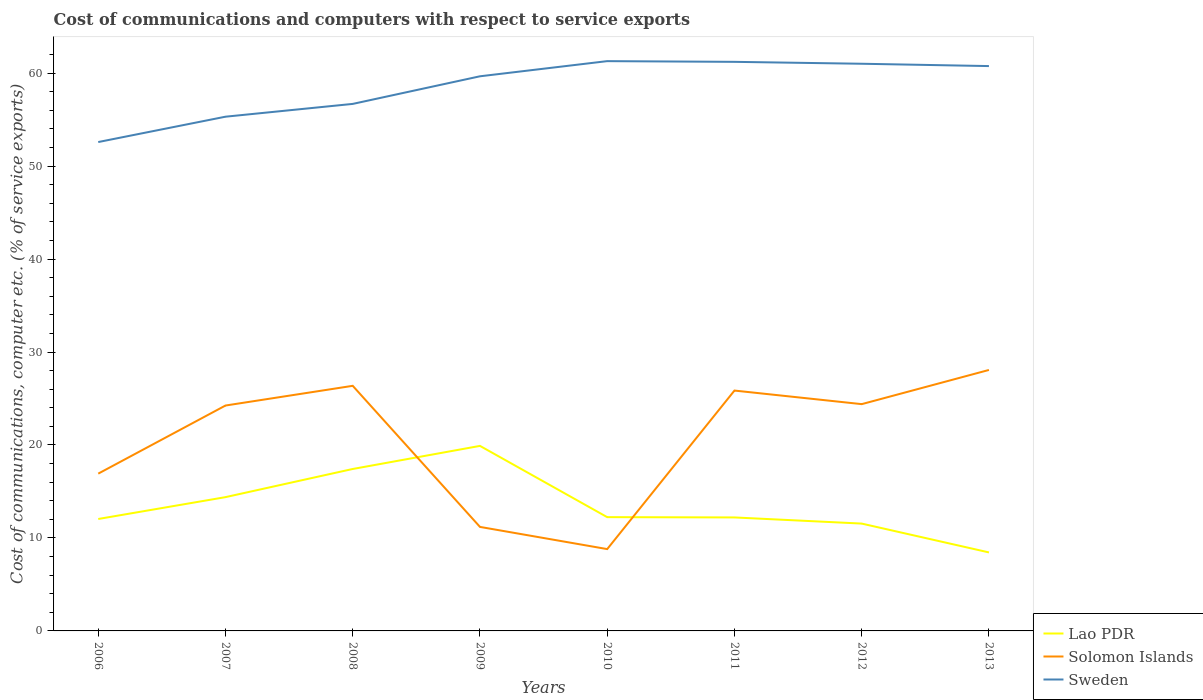Does the line corresponding to Solomon Islands intersect with the line corresponding to Lao PDR?
Your answer should be compact. Yes. Across all years, what is the maximum cost of communications and computers in Solomon Islands?
Keep it short and to the point. 8.8. In which year was the cost of communications and computers in Lao PDR maximum?
Offer a terse response. 2013. What is the total cost of communications and computers in Solomon Islands in the graph?
Ensure brevity in your answer.  8.12. What is the difference between the highest and the second highest cost of communications and computers in Solomon Islands?
Give a very brief answer. 19.27. What is the difference between the highest and the lowest cost of communications and computers in Sweden?
Your response must be concise. 5. Is the cost of communications and computers in Lao PDR strictly greater than the cost of communications and computers in Sweden over the years?
Keep it short and to the point. Yes. How many years are there in the graph?
Ensure brevity in your answer.  8. Does the graph contain any zero values?
Your response must be concise. No. Does the graph contain grids?
Make the answer very short. No. Where does the legend appear in the graph?
Offer a very short reply. Bottom right. How are the legend labels stacked?
Keep it short and to the point. Vertical. What is the title of the graph?
Make the answer very short. Cost of communications and computers with respect to service exports. What is the label or title of the X-axis?
Make the answer very short. Years. What is the label or title of the Y-axis?
Provide a short and direct response. Cost of communications, computer etc. (% of service exports). What is the Cost of communications, computer etc. (% of service exports) in Lao PDR in 2006?
Offer a terse response. 12.04. What is the Cost of communications, computer etc. (% of service exports) in Solomon Islands in 2006?
Offer a terse response. 16.92. What is the Cost of communications, computer etc. (% of service exports) of Sweden in 2006?
Provide a succinct answer. 52.59. What is the Cost of communications, computer etc. (% of service exports) of Lao PDR in 2007?
Your answer should be very brief. 14.39. What is the Cost of communications, computer etc. (% of service exports) in Solomon Islands in 2007?
Your answer should be compact. 24.25. What is the Cost of communications, computer etc. (% of service exports) in Sweden in 2007?
Your answer should be compact. 55.32. What is the Cost of communications, computer etc. (% of service exports) of Lao PDR in 2008?
Provide a short and direct response. 17.42. What is the Cost of communications, computer etc. (% of service exports) of Solomon Islands in 2008?
Your answer should be very brief. 26.37. What is the Cost of communications, computer etc. (% of service exports) of Sweden in 2008?
Your answer should be compact. 56.69. What is the Cost of communications, computer etc. (% of service exports) of Lao PDR in 2009?
Keep it short and to the point. 19.9. What is the Cost of communications, computer etc. (% of service exports) in Solomon Islands in 2009?
Your response must be concise. 11.19. What is the Cost of communications, computer etc. (% of service exports) of Sweden in 2009?
Keep it short and to the point. 59.66. What is the Cost of communications, computer etc. (% of service exports) of Lao PDR in 2010?
Your response must be concise. 12.24. What is the Cost of communications, computer etc. (% of service exports) in Solomon Islands in 2010?
Ensure brevity in your answer.  8.8. What is the Cost of communications, computer etc. (% of service exports) of Sweden in 2010?
Make the answer very short. 61.29. What is the Cost of communications, computer etc. (% of service exports) in Lao PDR in 2011?
Your answer should be compact. 12.21. What is the Cost of communications, computer etc. (% of service exports) in Solomon Islands in 2011?
Your answer should be very brief. 25.86. What is the Cost of communications, computer etc. (% of service exports) in Sweden in 2011?
Give a very brief answer. 61.22. What is the Cost of communications, computer etc. (% of service exports) of Lao PDR in 2012?
Ensure brevity in your answer.  11.55. What is the Cost of communications, computer etc. (% of service exports) in Solomon Islands in 2012?
Make the answer very short. 24.4. What is the Cost of communications, computer etc. (% of service exports) of Sweden in 2012?
Offer a terse response. 61.01. What is the Cost of communications, computer etc. (% of service exports) in Lao PDR in 2013?
Keep it short and to the point. 8.45. What is the Cost of communications, computer etc. (% of service exports) in Solomon Islands in 2013?
Your response must be concise. 28.07. What is the Cost of communications, computer etc. (% of service exports) in Sweden in 2013?
Give a very brief answer. 60.76. Across all years, what is the maximum Cost of communications, computer etc. (% of service exports) in Lao PDR?
Keep it short and to the point. 19.9. Across all years, what is the maximum Cost of communications, computer etc. (% of service exports) in Solomon Islands?
Provide a succinct answer. 28.07. Across all years, what is the maximum Cost of communications, computer etc. (% of service exports) in Sweden?
Offer a terse response. 61.29. Across all years, what is the minimum Cost of communications, computer etc. (% of service exports) of Lao PDR?
Your response must be concise. 8.45. Across all years, what is the minimum Cost of communications, computer etc. (% of service exports) of Solomon Islands?
Provide a short and direct response. 8.8. Across all years, what is the minimum Cost of communications, computer etc. (% of service exports) in Sweden?
Provide a short and direct response. 52.59. What is the total Cost of communications, computer etc. (% of service exports) in Lao PDR in the graph?
Offer a very short reply. 108.19. What is the total Cost of communications, computer etc. (% of service exports) of Solomon Islands in the graph?
Offer a terse response. 165.85. What is the total Cost of communications, computer etc. (% of service exports) in Sweden in the graph?
Your response must be concise. 468.54. What is the difference between the Cost of communications, computer etc. (% of service exports) of Lao PDR in 2006 and that in 2007?
Your answer should be compact. -2.35. What is the difference between the Cost of communications, computer etc. (% of service exports) in Solomon Islands in 2006 and that in 2007?
Provide a succinct answer. -7.33. What is the difference between the Cost of communications, computer etc. (% of service exports) of Sweden in 2006 and that in 2007?
Give a very brief answer. -2.73. What is the difference between the Cost of communications, computer etc. (% of service exports) in Lao PDR in 2006 and that in 2008?
Give a very brief answer. -5.38. What is the difference between the Cost of communications, computer etc. (% of service exports) in Solomon Islands in 2006 and that in 2008?
Make the answer very short. -9.45. What is the difference between the Cost of communications, computer etc. (% of service exports) in Sweden in 2006 and that in 2008?
Your answer should be compact. -4.1. What is the difference between the Cost of communications, computer etc. (% of service exports) of Lao PDR in 2006 and that in 2009?
Ensure brevity in your answer.  -7.86. What is the difference between the Cost of communications, computer etc. (% of service exports) of Solomon Islands in 2006 and that in 2009?
Make the answer very short. 5.73. What is the difference between the Cost of communications, computer etc. (% of service exports) in Sweden in 2006 and that in 2009?
Keep it short and to the point. -7.07. What is the difference between the Cost of communications, computer etc. (% of service exports) in Lao PDR in 2006 and that in 2010?
Keep it short and to the point. -0.2. What is the difference between the Cost of communications, computer etc. (% of service exports) of Solomon Islands in 2006 and that in 2010?
Your answer should be very brief. 8.12. What is the difference between the Cost of communications, computer etc. (% of service exports) in Sweden in 2006 and that in 2010?
Your answer should be very brief. -8.7. What is the difference between the Cost of communications, computer etc. (% of service exports) of Lao PDR in 2006 and that in 2011?
Give a very brief answer. -0.17. What is the difference between the Cost of communications, computer etc. (% of service exports) in Solomon Islands in 2006 and that in 2011?
Provide a short and direct response. -8.94. What is the difference between the Cost of communications, computer etc. (% of service exports) of Sweden in 2006 and that in 2011?
Provide a short and direct response. -8.63. What is the difference between the Cost of communications, computer etc. (% of service exports) of Lao PDR in 2006 and that in 2012?
Offer a terse response. 0.49. What is the difference between the Cost of communications, computer etc. (% of service exports) of Solomon Islands in 2006 and that in 2012?
Make the answer very short. -7.48. What is the difference between the Cost of communications, computer etc. (% of service exports) in Sweden in 2006 and that in 2012?
Offer a terse response. -8.42. What is the difference between the Cost of communications, computer etc. (% of service exports) in Lao PDR in 2006 and that in 2013?
Provide a short and direct response. 3.6. What is the difference between the Cost of communications, computer etc. (% of service exports) in Solomon Islands in 2006 and that in 2013?
Offer a terse response. -11.15. What is the difference between the Cost of communications, computer etc. (% of service exports) of Sweden in 2006 and that in 2013?
Offer a terse response. -8.17. What is the difference between the Cost of communications, computer etc. (% of service exports) of Lao PDR in 2007 and that in 2008?
Keep it short and to the point. -3.03. What is the difference between the Cost of communications, computer etc. (% of service exports) in Solomon Islands in 2007 and that in 2008?
Provide a succinct answer. -2.12. What is the difference between the Cost of communications, computer etc. (% of service exports) of Sweden in 2007 and that in 2008?
Provide a succinct answer. -1.38. What is the difference between the Cost of communications, computer etc. (% of service exports) of Lao PDR in 2007 and that in 2009?
Your answer should be compact. -5.51. What is the difference between the Cost of communications, computer etc. (% of service exports) of Solomon Islands in 2007 and that in 2009?
Your answer should be compact. 13.06. What is the difference between the Cost of communications, computer etc. (% of service exports) of Sweden in 2007 and that in 2009?
Provide a succinct answer. -4.35. What is the difference between the Cost of communications, computer etc. (% of service exports) of Lao PDR in 2007 and that in 2010?
Offer a very short reply. 2.15. What is the difference between the Cost of communications, computer etc. (% of service exports) of Solomon Islands in 2007 and that in 2010?
Ensure brevity in your answer.  15.44. What is the difference between the Cost of communications, computer etc. (% of service exports) of Sweden in 2007 and that in 2010?
Provide a short and direct response. -5.98. What is the difference between the Cost of communications, computer etc. (% of service exports) in Lao PDR in 2007 and that in 2011?
Give a very brief answer. 2.18. What is the difference between the Cost of communications, computer etc. (% of service exports) of Solomon Islands in 2007 and that in 2011?
Your response must be concise. -1.61. What is the difference between the Cost of communications, computer etc. (% of service exports) in Sweden in 2007 and that in 2011?
Offer a terse response. -5.9. What is the difference between the Cost of communications, computer etc. (% of service exports) in Lao PDR in 2007 and that in 2012?
Provide a succinct answer. 2.84. What is the difference between the Cost of communications, computer etc. (% of service exports) in Solomon Islands in 2007 and that in 2012?
Keep it short and to the point. -0.15. What is the difference between the Cost of communications, computer etc. (% of service exports) of Sweden in 2007 and that in 2012?
Your answer should be compact. -5.7. What is the difference between the Cost of communications, computer etc. (% of service exports) of Lao PDR in 2007 and that in 2013?
Ensure brevity in your answer.  5.95. What is the difference between the Cost of communications, computer etc. (% of service exports) in Solomon Islands in 2007 and that in 2013?
Make the answer very short. -3.83. What is the difference between the Cost of communications, computer etc. (% of service exports) in Sweden in 2007 and that in 2013?
Offer a terse response. -5.45. What is the difference between the Cost of communications, computer etc. (% of service exports) of Lao PDR in 2008 and that in 2009?
Your answer should be compact. -2.48. What is the difference between the Cost of communications, computer etc. (% of service exports) of Solomon Islands in 2008 and that in 2009?
Your answer should be compact. 15.18. What is the difference between the Cost of communications, computer etc. (% of service exports) of Sweden in 2008 and that in 2009?
Your response must be concise. -2.97. What is the difference between the Cost of communications, computer etc. (% of service exports) of Lao PDR in 2008 and that in 2010?
Your answer should be compact. 5.18. What is the difference between the Cost of communications, computer etc. (% of service exports) in Solomon Islands in 2008 and that in 2010?
Make the answer very short. 17.56. What is the difference between the Cost of communications, computer etc. (% of service exports) in Sweden in 2008 and that in 2010?
Provide a short and direct response. -4.6. What is the difference between the Cost of communications, computer etc. (% of service exports) in Lao PDR in 2008 and that in 2011?
Your answer should be compact. 5.21. What is the difference between the Cost of communications, computer etc. (% of service exports) of Solomon Islands in 2008 and that in 2011?
Your answer should be very brief. 0.51. What is the difference between the Cost of communications, computer etc. (% of service exports) in Sweden in 2008 and that in 2011?
Keep it short and to the point. -4.53. What is the difference between the Cost of communications, computer etc. (% of service exports) of Lao PDR in 2008 and that in 2012?
Provide a short and direct response. 5.87. What is the difference between the Cost of communications, computer etc. (% of service exports) of Solomon Islands in 2008 and that in 2012?
Give a very brief answer. 1.97. What is the difference between the Cost of communications, computer etc. (% of service exports) in Sweden in 2008 and that in 2012?
Give a very brief answer. -4.32. What is the difference between the Cost of communications, computer etc. (% of service exports) of Lao PDR in 2008 and that in 2013?
Your response must be concise. 8.97. What is the difference between the Cost of communications, computer etc. (% of service exports) in Solomon Islands in 2008 and that in 2013?
Your response must be concise. -1.71. What is the difference between the Cost of communications, computer etc. (% of service exports) in Sweden in 2008 and that in 2013?
Ensure brevity in your answer.  -4.07. What is the difference between the Cost of communications, computer etc. (% of service exports) in Lao PDR in 2009 and that in 2010?
Give a very brief answer. 7.67. What is the difference between the Cost of communications, computer etc. (% of service exports) of Solomon Islands in 2009 and that in 2010?
Offer a very short reply. 2.39. What is the difference between the Cost of communications, computer etc. (% of service exports) in Sweden in 2009 and that in 2010?
Ensure brevity in your answer.  -1.63. What is the difference between the Cost of communications, computer etc. (% of service exports) of Lao PDR in 2009 and that in 2011?
Provide a succinct answer. 7.7. What is the difference between the Cost of communications, computer etc. (% of service exports) of Solomon Islands in 2009 and that in 2011?
Provide a succinct answer. -14.67. What is the difference between the Cost of communications, computer etc. (% of service exports) in Sweden in 2009 and that in 2011?
Offer a terse response. -1.56. What is the difference between the Cost of communications, computer etc. (% of service exports) in Lao PDR in 2009 and that in 2012?
Ensure brevity in your answer.  8.36. What is the difference between the Cost of communications, computer etc. (% of service exports) in Solomon Islands in 2009 and that in 2012?
Your response must be concise. -13.21. What is the difference between the Cost of communications, computer etc. (% of service exports) of Sweden in 2009 and that in 2012?
Ensure brevity in your answer.  -1.35. What is the difference between the Cost of communications, computer etc. (% of service exports) of Lao PDR in 2009 and that in 2013?
Ensure brevity in your answer.  11.46. What is the difference between the Cost of communications, computer etc. (% of service exports) of Solomon Islands in 2009 and that in 2013?
Provide a succinct answer. -16.88. What is the difference between the Cost of communications, computer etc. (% of service exports) of Sweden in 2009 and that in 2013?
Provide a succinct answer. -1.1. What is the difference between the Cost of communications, computer etc. (% of service exports) in Lao PDR in 2010 and that in 2011?
Offer a terse response. 0.03. What is the difference between the Cost of communications, computer etc. (% of service exports) in Solomon Islands in 2010 and that in 2011?
Provide a short and direct response. -17.05. What is the difference between the Cost of communications, computer etc. (% of service exports) in Sweden in 2010 and that in 2011?
Offer a very short reply. 0.08. What is the difference between the Cost of communications, computer etc. (% of service exports) of Lao PDR in 2010 and that in 2012?
Offer a very short reply. 0.69. What is the difference between the Cost of communications, computer etc. (% of service exports) in Solomon Islands in 2010 and that in 2012?
Give a very brief answer. -15.59. What is the difference between the Cost of communications, computer etc. (% of service exports) of Sweden in 2010 and that in 2012?
Your response must be concise. 0.28. What is the difference between the Cost of communications, computer etc. (% of service exports) in Lao PDR in 2010 and that in 2013?
Your answer should be compact. 3.79. What is the difference between the Cost of communications, computer etc. (% of service exports) in Solomon Islands in 2010 and that in 2013?
Ensure brevity in your answer.  -19.27. What is the difference between the Cost of communications, computer etc. (% of service exports) in Sweden in 2010 and that in 2013?
Provide a short and direct response. 0.53. What is the difference between the Cost of communications, computer etc. (% of service exports) of Lao PDR in 2011 and that in 2012?
Provide a succinct answer. 0.66. What is the difference between the Cost of communications, computer etc. (% of service exports) in Solomon Islands in 2011 and that in 2012?
Your answer should be compact. 1.46. What is the difference between the Cost of communications, computer etc. (% of service exports) of Sweden in 2011 and that in 2012?
Keep it short and to the point. 0.21. What is the difference between the Cost of communications, computer etc. (% of service exports) in Lao PDR in 2011 and that in 2013?
Offer a terse response. 3.76. What is the difference between the Cost of communications, computer etc. (% of service exports) in Solomon Islands in 2011 and that in 2013?
Make the answer very short. -2.22. What is the difference between the Cost of communications, computer etc. (% of service exports) in Sweden in 2011 and that in 2013?
Ensure brevity in your answer.  0.46. What is the difference between the Cost of communications, computer etc. (% of service exports) in Lao PDR in 2012 and that in 2013?
Keep it short and to the point. 3.1. What is the difference between the Cost of communications, computer etc. (% of service exports) in Solomon Islands in 2012 and that in 2013?
Ensure brevity in your answer.  -3.68. What is the difference between the Cost of communications, computer etc. (% of service exports) of Sweden in 2012 and that in 2013?
Keep it short and to the point. 0.25. What is the difference between the Cost of communications, computer etc. (% of service exports) in Lao PDR in 2006 and the Cost of communications, computer etc. (% of service exports) in Solomon Islands in 2007?
Provide a succinct answer. -12.2. What is the difference between the Cost of communications, computer etc. (% of service exports) in Lao PDR in 2006 and the Cost of communications, computer etc. (% of service exports) in Sweden in 2007?
Your answer should be very brief. -43.27. What is the difference between the Cost of communications, computer etc. (% of service exports) of Solomon Islands in 2006 and the Cost of communications, computer etc. (% of service exports) of Sweden in 2007?
Give a very brief answer. -38.4. What is the difference between the Cost of communications, computer etc. (% of service exports) in Lao PDR in 2006 and the Cost of communications, computer etc. (% of service exports) in Solomon Islands in 2008?
Your answer should be very brief. -14.32. What is the difference between the Cost of communications, computer etc. (% of service exports) in Lao PDR in 2006 and the Cost of communications, computer etc. (% of service exports) in Sweden in 2008?
Your response must be concise. -44.65. What is the difference between the Cost of communications, computer etc. (% of service exports) in Solomon Islands in 2006 and the Cost of communications, computer etc. (% of service exports) in Sweden in 2008?
Provide a short and direct response. -39.77. What is the difference between the Cost of communications, computer etc. (% of service exports) of Lao PDR in 2006 and the Cost of communications, computer etc. (% of service exports) of Solomon Islands in 2009?
Your answer should be very brief. 0.85. What is the difference between the Cost of communications, computer etc. (% of service exports) in Lao PDR in 2006 and the Cost of communications, computer etc. (% of service exports) in Sweden in 2009?
Provide a succinct answer. -47.62. What is the difference between the Cost of communications, computer etc. (% of service exports) in Solomon Islands in 2006 and the Cost of communications, computer etc. (% of service exports) in Sweden in 2009?
Your response must be concise. -42.74. What is the difference between the Cost of communications, computer etc. (% of service exports) in Lao PDR in 2006 and the Cost of communications, computer etc. (% of service exports) in Solomon Islands in 2010?
Your answer should be very brief. 3.24. What is the difference between the Cost of communications, computer etc. (% of service exports) in Lao PDR in 2006 and the Cost of communications, computer etc. (% of service exports) in Sweden in 2010?
Offer a terse response. -49.25. What is the difference between the Cost of communications, computer etc. (% of service exports) of Solomon Islands in 2006 and the Cost of communications, computer etc. (% of service exports) of Sweden in 2010?
Make the answer very short. -44.37. What is the difference between the Cost of communications, computer etc. (% of service exports) in Lao PDR in 2006 and the Cost of communications, computer etc. (% of service exports) in Solomon Islands in 2011?
Make the answer very short. -13.81. What is the difference between the Cost of communications, computer etc. (% of service exports) in Lao PDR in 2006 and the Cost of communications, computer etc. (% of service exports) in Sweden in 2011?
Give a very brief answer. -49.18. What is the difference between the Cost of communications, computer etc. (% of service exports) of Solomon Islands in 2006 and the Cost of communications, computer etc. (% of service exports) of Sweden in 2011?
Your answer should be very brief. -44.3. What is the difference between the Cost of communications, computer etc. (% of service exports) in Lao PDR in 2006 and the Cost of communications, computer etc. (% of service exports) in Solomon Islands in 2012?
Provide a succinct answer. -12.35. What is the difference between the Cost of communications, computer etc. (% of service exports) in Lao PDR in 2006 and the Cost of communications, computer etc. (% of service exports) in Sweden in 2012?
Offer a terse response. -48.97. What is the difference between the Cost of communications, computer etc. (% of service exports) of Solomon Islands in 2006 and the Cost of communications, computer etc. (% of service exports) of Sweden in 2012?
Your response must be concise. -44.09. What is the difference between the Cost of communications, computer etc. (% of service exports) in Lao PDR in 2006 and the Cost of communications, computer etc. (% of service exports) in Solomon Islands in 2013?
Keep it short and to the point. -16.03. What is the difference between the Cost of communications, computer etc. (% of service exports) in Lao PDR in 2006 and the Cost of communications, computer etc. (% of service exports) in Sweden in 2013?
Give a very brief answer. -48.72. What is the difference between the Cost of communications, computer etc. (% of service exports) in Solomon Islands in 2006 and the Cost of communications, computer etc. (% of service exports) in Sweden in 2013?
Give a very brief answer. -43.84. What is the difference between the Cost of communications, computer etc. (% of service exports) of Lao PDR in 2007 and the Cost of communications, computer etc. (% of service exports) of Solomon Islands in 2008?
Offer a terse response. -11.97. What is the difference between the Cost of communications, computer etc. (% of service exports) of Lao PDR in 2007 and the Cost of communications, computer etc. (% of service exports) of Sweden in 2008?
Keep it short and to the point. -42.3. What is the difference between the Cost of communications, computer etc. (% of service exports) in Solomon Islands in 2007 and the Cost of communications, computer etc. (% of service exports) in Sweden in 2008?
Your answer should be compact. -32.45. What is the difference between the Cost of communications, computer etc. (% of service exports) in Lao PDR in 2007 and the Cost of communications, computer etc. (% of service exports) in Solomon Islands in 2009?
Keep it short and to the point. 3.2. What is the difference between the Cost of communications, computer etc. (% of service exports) of Lao PDR in 2007 and the Cost of communications, computer etc. (% of service exports) of Sweden in 2009?
Offer a very short reply. -45.27. What is the difference between the Cost of communications, computer etc. (% of service exports) in Solomon Islands in 2007 and the Cost of communications, computer etc. (% of service exports) in Sweden in 2009?
Offer a terse response. -35.42. What is the difference between the Cost of communications, computer etc. (% of service exports) of Lao PDR in 2007 and the Cost of communications, computer etc. (% of service exports) of Solomon Islands in 2010?
Provide a short and direct response. 5.59. What is the difference between the Cost of communications, computer etc. (% of service exports) in Lao PDR in 2007 and the Cost of communications, computer etc. (% of service exports) in Sweden in 2010?
Your answer should be very brief. -46.9. What is the difference between the Cost of communications, computer etc. (% of service exports) of Solomon Islands in 2007 and the Cost of communications, computer etc. (% of service exports) of Sweden in 2010?
Offer a terse response. -37.05. What is the difference between the Cost of communications, computer etc. (% of service exports) of Lao PDR in 2007 and the Cost of communications, computer etc. (% of service exports) of Solomon Islands in 2011?
Your answer should be compact. -11.46. What is the difference between the Cost of communications, computer etc. (% of service exports) in Lao PDR in 2007 and the Cost of communications, computer etc. (% of service exports) in Sweden in 2011?
Keep it short and to the point. -46.83. What is the difference between the Cost of communications, computer etc. (% of service exports) of Solomon Islands in 2007 and the Cost of communications, computer etc. (% of service exports) of Sweden in 2011?
Your answer should be very brief. -36.97. What is the difference between the Cost of communications, computer etc. (% of service exports) in Lao PDR in 2007 and the Cost of communications, computer etc. (% of service exports) in Solomon Islands in 2012?
Your response must be concise. -10. What is the difference between the Cost of communications, computer etc. (% of service exports) of Lao PDR in 2007 and the Cost of communications, computer etc. (% of service exports) of Sweden in 2012?
Ensure brevity in your answer.  -46.62. What is the difference between the Cost of communications, computer etc. (% of service exports) in Solomon Islands in 2007 and the Cost of communications, computer etc. (% of service exports) in Sweden in 2012?
Ensure brevity in your answer.  -36.77. What is the difference between the Cost of communications, computer etc. (% of service exports) of Lao PDR in 2007 and the Cost of communications, computer etc. (% of service exports) of Solomon Islands in 2013?
Keep it short and to the point. -13.68. What is the difference between the Cost of communications, computer etc. (% of service exports) in Lao PDR in 2007 and the Cost of communications, computer etc. (% of service exports) in Sweden in 2013?
Keep it short and to the point. -46.37. What is the difference between the Cost of communications, computer etc. (% of service exports) of Solomon Islands in 2007 and the Cost of communications, computer etc. (% of service exports) of Sweden in 2013?
Make the answer very short. -36.52. What is the difference between the Cost of communications, computer etc. (% of service exports) in Lao PDR in 2008 and the Cost of communications, computer etc. (% of service exports) in Solomon Islands in 2009?
Your response must be concise. 6.23. What is the difference between the Cost of communications, computer etc. (% of service exports) of Lao PDR in 2008 and the Cost of communications, computer etc. (% of service exports) of Sweden in 2009?
Make the answer very short. -42.24. What is the difference between the Cost of communications, computer etc. (% of service exports) of Solomon Islands in 2008 and the Cost of communications, computer etc. (% of service exports) of Sweden in 2009?
Provide a succinct answer. -33.3. What is the difference between the Cost of communications, computer etc. (% of service exports) in Lao PDR in 2008 and the Cost of communications, computer etc. (% of service exports) in Solomon Islands in 2010?
Make the answer very short. 8.62. What is the difference between the Cost of communications, computer etc. (% of service exports) in Lao PDR in 2008 and the Cost of communications, computer etc. (% of service exports) in Sweden in 2010?
Your answer should be compact. -43.87. What is the difference between the Cost of communications, computer etc. (% of service exports) of Solomon Islands in 2008 and the Cost of communications, computer etc. (% of service exports) of Sweden in 2010?
Your answer should be compact. -34.93. What is the difference between the Cost of communications, computer etc. (% of service exports) in Lao PDR in 2008 and the Cost of communications, computer etc. (% of service exports) in Solomon Islands in 2011?
Provide a short and direct response. -8.44. What is the difference between the Cost of communications, computer etc. (% of service exports) of Lao PDR in 2008 and the Cost of communications, computer etc. (% of service exports) of Sweden in 2011?
Make the answer very short. -43.8. What is the difference between the Cost of communications, computer etc. (% of service exports) of Solomon Islands in 2008 and the Cost of communications, computer etc. (% of service exports) of Sweden in 2011?
Provide a short and direct response. -34.85. What is the difference between the Cost of communications, computer etc. (% of service exports) in Lao PDR in 2008 and the Cost of communications, computer etc. (% of service exports) in Solomon Islands in 2012?
Offer a very short reply. -6.98. What is the difference between the Cost of communications, computer etc. (% of service exports) of Lao PDR in 2008 and the Cost of communications, computer etc. (% of service exports) of Sweden in 2012?
Offer a terse response. -43.59. What is the difference between the Cost of communications, computer etc. (% of service exports) in Solomon Islands in 2008 and the Cost of communications, computer etc. (% of service exports) in Sweden in 2012?
Give a very brief answer. -34.65. What is the difference between the Cost of communications, computer etc. (% of service exports) in Lao PDR in 2008 and the Cost of communications, computer etc. (% of service exports) in Solomon Islands in 2013?
Offer a terse response. -10.65. What is the difference between the Cost of communications, computer etc. (% of service exports) in Lao PDR in 2008 and the Cost of communications, computer etc. (% of service exports) in Sweden in 2013?
Make the answer very short. -43.34. What is the difference between the Cost of communications, computer etc. (% of service exports) of Solomon Islands in 2008 and the Cost of communications, computer etc. (% of service exports) of Sweden in 2013?
Ensure brevity in your answer.  -34.4. What is the difference between the Cost of communications, computer etc. (% of service exports) of Lao PDR in 2009 and the Cost of communications, computer etc. (% of service exports) of Solomon Islands in 2010?
Provide a succinct answer. 11.1. What is the difference between the Cost of communications, computer etc. (% of service exports) in Lao PDR in 2009 and the Cost of communications, computer etc. (% of service exports) in Sweden in 2010?
Your answer should be compact. -41.39. What is the difference between the Cost of communications, computer etc. (% of service exports) in Solomon Islands in 2009 and the Cost of communications, computer etc. (% of service exports) in Sweden in 2010?
Your response must be concise. -50.1. What is the difference between the Cost of communications, computer etc. (% of service exports) in Lao PDR in 2009 and the Cost of communications, computer etc. (% of service exports) in Solomon Islands in 2011?
Ensure brevity in your answer.  -5.95. What is the difference between the Cost of communications, computer etc. (% of service exports) in Lao PDR in 2009 and the Cost of communications, computer etc. (% of service exports) in Sweden in 2011?
Make the answer very short. -41.31. What is the difference between the Cost of communications, computer etc. (% of service exports) in Solomon Islands in 2009 and the Cost of communications, computer etc. (% of service exports) in Sweden in 2011?
Keep it short and to the point. -50.03. What is the difference between the Cost of communications, computer etc. (% of service exports) of Lao PDR in 2009 and the Cost of communications, computer etc. (% of service exports) of Solomon Islands in 2012?
Your answer should be very brief. -4.49. What is the difference between the Cost of communications, computer etc. (% of service exports) in Lao PDR in 2009 and the Cost of communications, computer etc. (% of service exports) in Sweden in 2012?
Offer a very short reply. -41.11. What is the difference between the Cost of communications, computer etc. (% of service exports) in Solomon Islands in 2009 and the Cost of communications, computer etc. (% of service exports) in Sweden in 2012?
Your response must be concise. -49.82. What is the difference between the Cost of communications, computer etc. (% of service exports) of Lao PDR in 2009 and the Cost of communications, computer etc. (% of service exports) of Solomon Islands in 2013?
Your answer should be very brief. -8.17. What is the difference between the Cost of communications, computer etc. (% of service exports) of Lao PDR in 2009 and the Cost of communications, computer etc. (% of service exports) of Sweden in 2013?
Make the answer very short. -40.86. What is the difference between the Cost of communications, computer etc. (% of service exports) in Solomon Islands in 2009 and the Cost of communications, computer etc. (% of service exports) in Sweden in 2013?
Provide a succinct answer. -49.57. What is the difference between the Cost of communications, computer etc. (% of service exports) of Lao PDR in 2010 and the Cost of communications, computer etc. (% of service exports) of Solomon Islands in 2011?
Ensure brevity in your answer.  -13.62. What is the difference between the Cost of communications, computer etc. (% of service exports) of Lao PDR in 2010 and the Cost of communications, computer etc. (% of service exports) of Sweden in 2011?
Give a very brief answer. -48.98. What is the difference between the Cost of communications, computer etc. (% of service exports) of Solomon Islands in 2010 and the Cost of communications, computer etc. (% of service exports) of Sweden in 2011?
Your response must be concise. -52.41. What is the difference between the Cost of communications, computer etc. (% of service exports) of Lao PDR in 2010 and the Cost of communications, computer etc. (% of service exports) of Solomon Islands in 2012?
Offer a terse response. -12.16. What is the difference between the Cost of communications, computer etc. (% of service exports) in Lao PDR in 2010 and the Cost of communications, computer etc. (% of service exports) in Sweden in 2012?
Provide a succinct answer. -48.77. What is the difference between the Cost of communications, computer etc. (% of service exports) in Solomon Islands in 2010 and the Cost of communications, computer etc. (% of service exports) in Sweden in 2012?
Provide a short and direct response. -52.21. What is the difference between the Cost of communications, computer etc. (% of service exports) of Lao PDR in 2010 and the Cost of communications, computer etc. (% of service exports) of Solomon Islands in 2013?
Ensure brevity in your answer.  -15.83. What is the difference between the Cost of communications, computer etc. (% of service exports) of Lao PDR in 2010 and the Cost of communications, computer etc. (% of service exports) of Sweden in 2013?
Offer a terse response. -48.52. What is the difference between the Cost of communications, computer etc. (% of service exports) of Solomon Islands in 2010 and the Cost of communications, computer etc. (% of service exports) of Sweden in 2013?
Keep it short and to the point. -51.96. What is the difference between the Cost of communications, computer etc. (% of service exports) in Lao PDR in 2011 and the Cost of communications, computer etc. (% of service exports) in Solomon Islands in 2012?
Make the answer very short. -12.19. What is the difference between the Cost of communications, computer etc. (% of service exports) of Lao PDR in 2011 and the Cost of communications, computer etc. (% of service exports) of Sweden in 2012?
Provide a short and direct response. -48.8. What is the difference between the Cost of communications, computer etc. (% of service exports) of Solomon Islands in 2011 and the Cost of communications, computer etc. (% of service exports) of Sweden in 2012?
Provide a succinct answer. -35.16. What is the difference between the Cost of communications, computer etc. (% of service exports) in Lao PDR in 2011 and the Cost of communications, computer etc. (% of service exports) in Solomon Islands in 2013?
Make the answer very short. -15.87. What is the difference between the Cost of communications, computer etc. (% of service exports) of Lao PDR in 2011 and the Cost of communications, computer etc. (% of service exports) of Sweden in 2013?
Your answer should be very brief. -48.55. What is the difference between the Cost of communications, computer etc. (% of service exports) of Solomon Islands in 2011 and the Cost of communications, computer etc. (% of service exports) of Sweden in 2013?
Offer a terse response. -34.91. What is the difference between the Cost of communications, computer etc. (% of service exports) of Lao PDR in 2012 and the Cost of communications, computer etc. (% of service exports) of Solomon Islands in 2013?
Make the answer very short. -16.53. What is the difference between the Cost of communications, computer etc. (% of service exports) in Lao PDR in 2012 and the Cost of communications, computer etc. (% of service exports) in Sweden in 2013?
Make the answer very short. -49.21. What is the difference between the Cost of communications, computer etc. (% of service exports) of Solomon Islands in 2012 and the Cost of communications, computer etc. (% of service exports) of Sweden in 2013?
Your response must be concise. -36.37. What is the average Cost of communications, computer etc. (% of service exports) of Lao PDR per year?
Give a very brief answer. 13.52. What is the average Cost of communications, computer etc. (% of service exports) in Solomon Islands per year?
Give a very brief answer. 20.73. What is the average Cost of communications, computer etc. (% of service exports) in Sweden per year?
Provide a short and direct response. 58.57. In the year 2006, what is the difference between the Cost of communications, computer etc. (% of service exports) of Lao PDR and Cost of communications, computer etc. (% of service exports) of Solomon Islands?
Ensure brevity in your answer.  -4.88. In the year 2006, what is the difference between the Cost of communications, computer etc. (% of service exports) of Lao PDR and Cost of communications, computer etc. (% of service exports) of Sweden?
Offer a terse response. -40.55. In the year 2006, what is the difference between the Cost of communications, computer etc. (% of service exports) of Solomon Islands and Cost of communications, computer etc. (% of service exports) of Sweden?
Your answer should be very brief. -35.67. In the year 2007, what is the difference between the Cost of communications, computer etc. (% of service exports) of Lao PDR and Cost of communications, computer etc. (% of service exports) of Solomon Islands?
Your answer should be very brief. -9.85. In the year 2007, what is the difference between the Cost of communications, computer etc. (% of service exports) of Lao PDR and Cost of communications, computer etc. (% of service exports) of Sweden?
Your answer should be very brief. -40.92. In the year 2007, what is the difference between the Cost of communications, computer etc. (% of service exports) of Solomon Islands and Cost of communications, computer etc. (% of service exports) of Sweden?
Offer a terse response. -31.07. In the year 2008, what is the difference between the Cost of communications, computer etc. (% of service exports) in Lao PDR and Cost of communications, computer etc. (% of service exports) in Solomon Islands?
Make the answer very short. -8.95. In the year 2008, what is the difference between the Cost of communications, computer etc. (% of service exports) in Lao PDR and Cost of communications, computer etc. (% of service exports) in Sweden?
Ensure brevity in your answer.  -39.27. In the year 2008, what is the difference between the Cost of communications, computer etc. (% of service exports) of Solomon Islands and Cost of communications, computer etc. (% of service exports) of Sweden?
Ensure brevity in your answer.  -30.33. In the year 2009, what is the difference between the Cost of communications, computer etc. (% of service exports) of Lao PDR and Cost of communications, computer etc. (% of service exports) of Solomon Islands?
Provide a succinct answer. 8.71. In the year 2009, what is the difference between the Cost of communications, computer etc. (% of service exports) in Lao PDR and Cost of communications, computer etc. (% of service exports) in Sweden?
Provide a succinct answer. -39.76. In the year 2009, what is the difference between the Cost of communications, computer etc. (% of service exports) of Solomon Islands and Cost of communications, computer etc. (% of service exports) of Sweden?
Provide a succinct answer. -48.47. In the year 2010, what is the difference between the Cost of communications, computer etc. (% of service exports) of Lao PDR and Cost of communications, computer etc. (% of service exports) of Solomon Islands?
Make the answer very short. 3.44. In the year 2010, what is the difference between the Cost of communications, computer etc. (% of service exports) in Lao PDR and Cost of communications, computer etc. (% of service exports) in Sweden?
Your response must be concise. -49.05. In the year 2010, what is the difference between the Cost of communications, computer etc. (% of service exports) of Solomon Islands and Cost of communications, computer etc. (% of service exports) of Sweden?
Your answer should be very brief. -52.49. In the year 2011, what is the difference between the Cost of communications, computer etc. (% of service exports) in Lao PDR and Cost of communications, computer etc. (% of service exports) in Solomon Islands?
Give a very brief answer. -13.65. In the year 2011, what is the difference between the Cost of communications, computer etc. (% of service exports) of Lao PDR and Cost of communications, computer etc. (% of service exports) of Sweden?
Your answer should be compact. -49.01. In the year 2011, what is the difference between the Cost of communications, computer etc. (% of service exports) of Solomon Islands and Cost of communications, computer etc. (% of service exports) of Sweden?
Make the answer very short. -35.36. In the year 2012, what is the difference between the Cost of communications, computer etc. (% of service exports) in Lao PDR and Cost of communications, computer etc. (% of service exports) in Solomon Islands?
Your answer should be compact. -12.85. In the year 2012, what is the difference between the Cost of communications, computer etc. (% of service exports) of Lao PDR and Cost of communications, computer etc. (% of service exports) of Sweden?
Provide a succinct answer. -49.47. In the year 2012, what is the difference between the Cost of communications, computer etc. (% of service exports) of Solomon Islands and Cost of communications, computer etc. (% of service exports) of Sweden?
Your response must be concise. -36.62. In the year 2013, what is the difference between the Cost of communications, computer etc. (% of service exports) in Lao PDR and Cost of communications, computer etc. (% of service exports) in Solomon Islands?
Keep it short and to the point. -19.63. In the year 2013, what is the difference between the Cost of communications, computer etc. (% of service exports) in Lao PDR and Cost of communications, computer etc. (% of service exports) in Sweden?
Provide a succinct answer. -52.32. In the year 2013, what is the difference between the Cost of communications, computer etc. (% of service exports) of Solomon Islands and Cost of communications, computer etc. (% of service exports) of Sweden?
Keep it short and to the point. -32.69. What is the ratio of the Cost of communications, computer etc. (% of service exports) of Lao PDR in 2006 to that in 2007?
Provide a succinct answer. 0.84. What is the ratio of the Cost of communications, computer etc. (% of service exports) in Solomon Islands in 2006 to that in 2007?
Offer a terse response. 0.7. What is the ratio of the Cost of communications, computer etc. (% of service exports) of Sweden in 2006 to that in 2007?
Provide a succinct answer. 0.95. What is the ratio of the Cost of communications, computer etc. (% of service exports) in Lao PDR in 2006 to that in 2008?
Provide a succinct answer. 0.69. What is the ratio of the Cost of communications, computer etc. (% of service exports) of Solomon Islands in 2006 to that in 2008?
Make the answer very short. 0.64. What is the ratio of the Cost of communications, computer etc. (% of service exports) in Sweden in 2006 to that in 2008?
Your answer should be compact. 0.93. What is the ratio of the Cost of communications, computer etc. (% of service exports) in Lao PDR in 2006 to that in 2009?
Ensure brevity in your answer.  0.6. What is the ratio of the Cost of communications, computer etc. (% of service exports) of Solomon Islands in 2006 to that in 2009?
Provide a succinct answer. 1.51. What is the ratio of the Cost of communications, computer etc. (% of service exports) of Sweden in 2006 to that in 2009?
Offer a very short reply. 0.88. What is the ratio of the Cost of communications, computer etc. (% of service exports) in Lao PDR in 2006 to that in 2010?
Your answer should be very brief. 0.98. What is the ratio of the Cost of communications, computer etc. (% of service exports) in Solomon Islands in 2006 to that in 2010?
Ensure brevity in your answer.  1.92. What is the ratio of the Cost of communications, computer etc. (% of service exports) in Sweden in 2006 to that in 2010?
Give a very brief answer. 0.86. What is the ratio of the Cost of communications, computer etc. (% of service exports) of Lao PDR in 2006 to that in 2011?
Offer a very short reply. 0.99. What is the ratio of the Cost of communications, computer etc. (% of service exports) of Solomon Islands in 2006 to that in 2011?
Make the answer very short. 0.65. What is the ratio of the Cost of communications, computer etc. (% of service exports) of Sweden in 2006 to that in 2011?
Offer a very short reply. 0.86. What is the ratio of the Cost of communications, computer etc. (% of service exports) in Lao PDR in 2006 to that in 2012?
Provide a short and direct response. 1.04. What is the ratio of the Cost of communications, computer etc. (% of service exports) in Solomon Islands in 2006 to that in 2012?
Ensure brevity in your answer.  0.69. What is the ratio of the Cost of communications, computer etc. (% of service exports) in Sweden in 2006 to that in 2012?
Make the answer very short. 0.86. What is the ratio of the Cost of communications, computer etc. (% of service exports) in Lao PDR in 2006 to that in 2013?
Provide a short and direct response. 1.43. What is the ratio of the Cost of communications, computer etc. (% of service exports) of Solomon Islands in 2006 to that in 2013?
Give a very brief answer. 0.6. What is the ratio of the Cost of communications, computer etc. (% of service exports) of Sweden in 2006 to that in 2013?
Provide a succinct answer. 0.87. What is the ratio of the Cost of communications, computer etc. (% of service exports) of Lao PDR in 2007 to that in 2008?
Give a very brief answer. 0.83. What is the ratio of the Cost of communications, computer etc. (% of service exports) of Solomon Islands in 2007 to that in 2008?
Offer a very short reply. 0.92. What is the ratio of the Cost of communications, computer etc. (% of service exports) of Sweden in 2007 to that in 2008?
Your answer should be compact. 0.98. What is the ratio of the Cost of communications, computer etc. (% of service exports) in Lao PDR in 2007 to that in 2009?
Make the answer very short. 0.72. What is the ratio of the Cost of communications, computer etc. (% of service exports) of Solomon Islands in 2007 to that in 2009?
Offer a very short reply. 2.17. What is the ratio of the Cost of communications, computer etc. (% of service exports) of Sweden in 2007 to that in 2009?
Your answer should be compact. 0.93. What is the ratio of the Cost of communications, computer etc. (% of service exports) in Lao PDR in 2007 to that in 2010?
Your answer should be very brief. 1.18. What is the ratio of the Cost of communications, computer etc. (% of service exports) in Solomon Islands in 2007 to that in 2010?
Provide a short and direct response. 2.75. What is the ratio of the Cost of communications, computer etc. (% of service exports) in Sweden in 2007 to that in 2010?
Your answer should be very brief. 0.9. What is the ratio of the Cost of communications, computer etc. (% of service exports) in Lao PDR in 2007 to that in 2011?
Your answer should be very brief. 1.18. What is the ratio of the Cost of communications, computer etc. (% of service exports) of Solomon Islands in 2007 to that in 2011?
Make the answer very short. 0.94. What is the ratio of the Cost of communications, computer etc. (% of service exports) in Sweden in 2007 to that in 2011?
Give a very brief answer. 0.9. What is the ratio of the Cost of communications, computer etc. (% of service exports) in Lao PDR in 2007 to that in 2012?
Make the answer very short. 1.25. What is the ratio of the Cost of communications, computer etc. (% of service exports) of Sweden in 2007 to that in 2012?
Provide a succinct answer. 0.91. What is the ratio of the Cost of communications, computer etc. (% of service exports) in Lao PDR in 2007 to that in 2013?
Offer a very short reply. 1.7. What is the ratio of the Cost of communications, computer etc. (% of service exports) of Solomon Islands in 2007 to that in 2013?
Give a very brief answer. 0.86. What is the ratio of the Cost of communications, computer etc. (% of service exports) in Sweden in 2007 to that in 2013?
Your response must be concise. 0.91. What is the ratio of the Cost of communications, computer etc. (% of service exports) in Lao PDR in 2008 to that in 2009?
Ensure brevity in your answer.  0.88. What is the ratio of the Cost of communications, computer etc. (% of service exports) in Solomon Islands in 2008 to that in 2009?
Ensure brevity in your answer.  2.36. What is the ratio of the Cost of communications, computer etc. (% of service exports) of Sweden in 2008 to that in 2009?
Make the answer very short. 0.95. What is the ratio of the Cost of communications, computer etc. (% of service exports) in Lao PDR in 2008 to that in 2010?
Provide a succinct answer. 1.42. What is the ratio of the Cost of communications, computer etc. (% of service exports) in Solomon Islands in 2008 to that in 2010?
Give a very brief answer. 3. What is the ratio of the Cost of communications, computer etc. (% of service exports) in Sweden in 2008 to that in 2010?
Keep it short and to the point. 0.92. What is the ratio of the Cost of communications, computer etc. (% of service exports) of Lao PDR in 2008 to that in 2011?
Offer a very short reply. 1.43. What is the ratio of the Cost of communications, computer etc. (% of service exports) of Solomon Islands in 2008 to that in 2011?
Offer a terse response. 1.02. What is the ratio of the Cost of communications, computer etc. (% of service exports) of Sweden in 2008 to that in 2011?
Ensure brevity in your answer.  0.93. What is the ratio of the Cost of communications, computer etc. (% of service exports) in Lao PDR in 2008 to that in 2012?
Provide a short and direct response. 1.51. What is the ratio of the Cost of communications, computer etc. (% of service exports) in Solomon Islands in 2008 to that in 2012?
Your response must be concise. 1.08. What is the ratio of the Cost of communications, computer etc. (% of service exports) of Sweden in 2008 to that in 2012?
Your response must be concise. 0.93. What is the ratio of the Cost of communications, computer etc. (% of service exports) of Lao PDR in 2008 to that in 2013?
Offer a terse response. 2.06. What is the ratio of the Cost of communications, computer etc. (% of service exports) of Solomon Islands in 2008 to that in 2013?
Provide a succinct answer. 0.94. What is the ratio of the Cost of communications, computer etc. (% of service exports) of Sweden in 2008 to that in 2013?
Provide a short and direct response. 0.93. What is the ratio of the Cost of communications, computer etc. (% of service exports) in Lao PDR in 2009 to that in 2010?
Give a very brief answer. 1.63. What is the ratio of the Cost of communications, computer etc. (% of service exports) in Solomon Islands in 2009 to that in 2010?
Make the answer very short. 1.27. What is the ratio of the Cost of communications, computer etc. (% of service exports) of Sweden in 2009 to that in 2010?
Your answer should be very brief. 0.97. What is the ratio of the Cost of communications, computer etc. (% of service exports) in Lao PDR in 2009 to that in 2011?
Your answer should be compact. 1.63. What is the ratio of the Cost of communications, computer etc. (% of service exports) of Solomon Islands in 2009 to that in 2011?
Your response must be concise. 0.43. What is the ratio of the Cost of communications, computer etc. (% of service exports) in Sweden in 2009 to that in 2011?
Your answer should be very brief. 0.97. What is the ratio of the Cost of communications, computer etc. (% of service exports) in Lao PDR in 2009 to that in 2012?
Keep it short and to the point. 1.72. What is the ratio of the Cost of communications, computer etc. (% of service exports) in Solomon Islands in 2009 to that in 2012?
Give a very brief answer. 0.46. What is the ratio of the Cost of communications, computer etc. (% of service exports) in Sweden in 2009 to that in 2012?
Offer a very short reply. 0.98. What is the ratio of the Cost of communications, computer etc. (% of service exports) in Lao PDR in 2009 to that in 2013?
Provide a short and direct response. 2.36. What is the ratio of the Cost of communications, computer etc. (% of service exports) of Solomon Islands in 2009 to that in 2013?
Make the answer very short. 0.4. What is the ratio of the Cost of communications, computer etc. (% of service exports) in Sweden in 2009 to that in 2013?
Your answer should be compact. 0.98. What is the ratio of the Cost of communications, computer etc. (% of service exports) of Lao PDR in 2010 to that in 2011?
Provide a short and direct response. 1. What is the ratio of the Cost of communications, computer etc. (% of service exports) of Solomon Islands in 2010 to that in 2011?
Offer a terse response. 0.34. What is the ratio of the Cost of communications, computer etc. (% of service exports) of Sweden in 2010 to that in 2011?
Your answer should be very brief. 1. What is the ratio of the Cost of communications, computer etc. (% of service exports) in Lao PDR in 2010 to that in 2012?
Ensure brevity in your answer.  1.06. What is the ratio of the Cost of communications, computer etc. (% of service exports) of Solomon Islands in 2010 to that in 2012?
Your answer should be compact. 0.36. What is the ratio of the Cost of communications, computer etc. (% of service exports) in Lao PDR in 2010 to that in 2013?
Provide a succinct answer. 1.45. What is the ratio of the Cost of communications, computer etc. (% of service exports) of Solomon Islands in 2010 to that in 2013?
Your response must be concise. 0.31. What is the ratio of the Cost of communications, computer etc. (% of service exports) of Sweden in 2010 to that in 2013?
Ensure brevity in your answer.  1.01. What is the ratio of the Cost of communications, computer etc. (% of service exports) of Lao PDR in 2011 to that in 2012?
Offer a terse response. 1.06. What is the ratio of the Cost of communications, computer etc. (% of service exports) of Solomon Islands in 2011 to that in 2012?
Your answer should be very brief. 1.06. What is the ratio of the Cost of communications, computer etc. (% of service exports) of Lao PDR in 2011 to that in 2013?
Offer a terse response. 1.45. What is the ratio of the Cost of communications, computer etc. (% of service exports) in Solomon Islands in 2011 to that in 2013?
Ensure brevity in your answer.  0.92. What is the ratio of the Cost of communications, computer etc. (% of service exports) of Sweden in 2011 to that in 2013?
Offer a terse response. 1.01. What is the ratio of the Cost of communications, computer etc. (% of service exports) in Lao PDR in 2012 to that in 2013?
Provide a succinct answer. 1.37. What is the ratio of the Cost of communications, computer etc. (% of service exports) in Solomon Islands in 2012 to that in 2013?
Your answer should be very brief. 0.87. What is the difference between the highest and the second highest Cost of communications, computer etc. (% of service exports) in Lao PDR?
Keep it short and to the point. 2.48. What is the difference between the highest and the second highest Cost of communications, computer etc. (% of service exports) in Solomon Islands?
Provide a succinct answer. 1.71. What is the difference between the highest and the second highest Cost of communications, computer etc. (% of service exports) of Sweden?
Keep it short and to the point. 0.08. What is the difference between the highest and the lowest Cost of communications, computer etc. (% of service exports) in Lao PDR?
Provide a short and direct response. 11.46. What is the difference between the highest and the lowest Cost of communications, computer etc. (% of service exports) in Solomon Islands?
Ensure brevity in your answer.  19.27. What is the difference between the highest and the lowest Cost of communications, computer etc. (% of service exports) in Sweden?
Offer a very short reply. 8.7. 